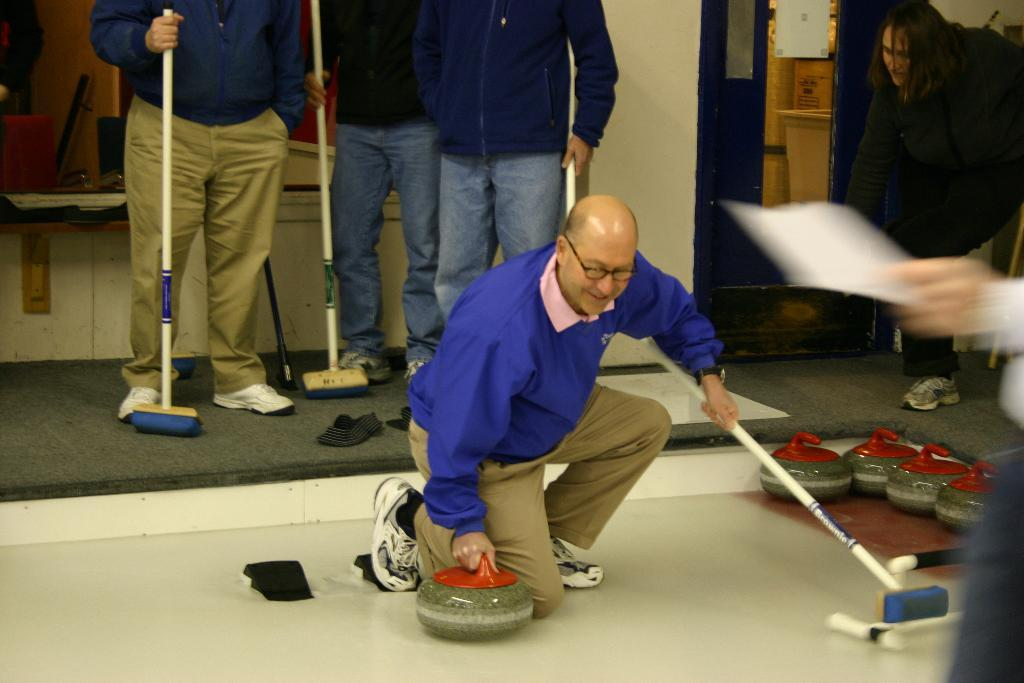Who is the person in the image? There is a man in the image. What is the man wearing? The man is wearing a purple jacket and brown pants. What is the man doing in the image? The man is cleaning the floor with a mop. Can you describe the setting of the image? The image was taken inside a room. Are there any other people visible in the image? Yes, there are people standing in the background of the image. What type of spiders can be seen on the stage in the image? There is no stage or spiders present in the image. 